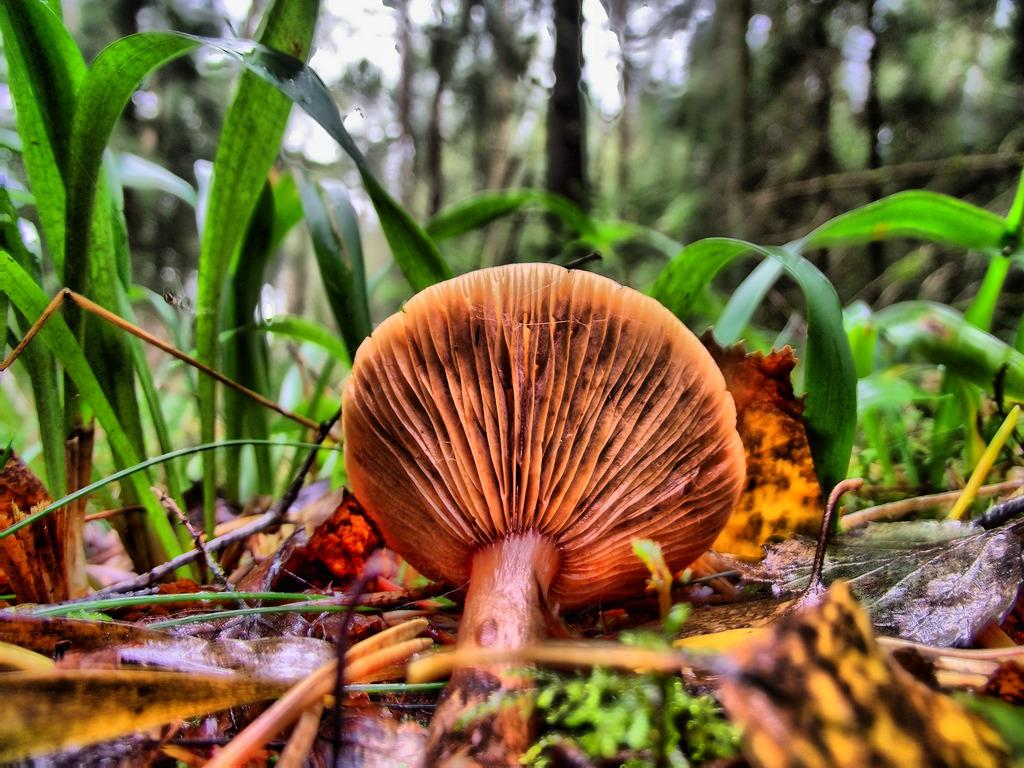What is the main subject of the image? The main subject of the image is a mushroom. Where is the mushroom located in the image? The mushroom is on the land in the image. What other types of vegetation can be seen in the image? There are plants, leaves, and trees present in the image. What can be seen in the background of the image? Trees can be seen in the background of the image. What unit of time is represented by the hourglass in the image? There is no hourglass present in the image; it features a mushroom and various types of vegetation. What type of cap is worn by the person in the image? There is no person present in the image, only a mushroom and vegetation. 